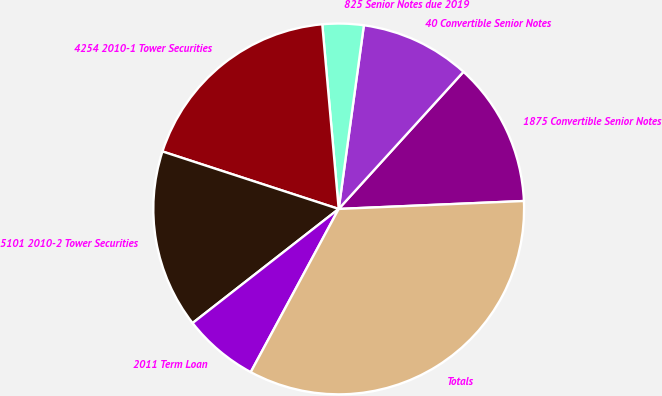Convert chart to OTSL. <chart><loc_0><loc_0><loc_500><loc_500><pie_chart><fcel>1875 Convertible Senior Notes<fcel>40 Convertible Senior Notes<fcel>825 Senior Notes due 2019<fcel>4254 2010-1 Tower Securities<fcel>5101 2010-2 Tower Securities<fcel>2011 Term Loan<fcel>Totals<nl><fcel>12.57%<fcel>9.58%<fcel>3.58%<fcel>18.57%<fcel>15.57%<fcel>6.58%<fcel>33.55%<nl></chart> 